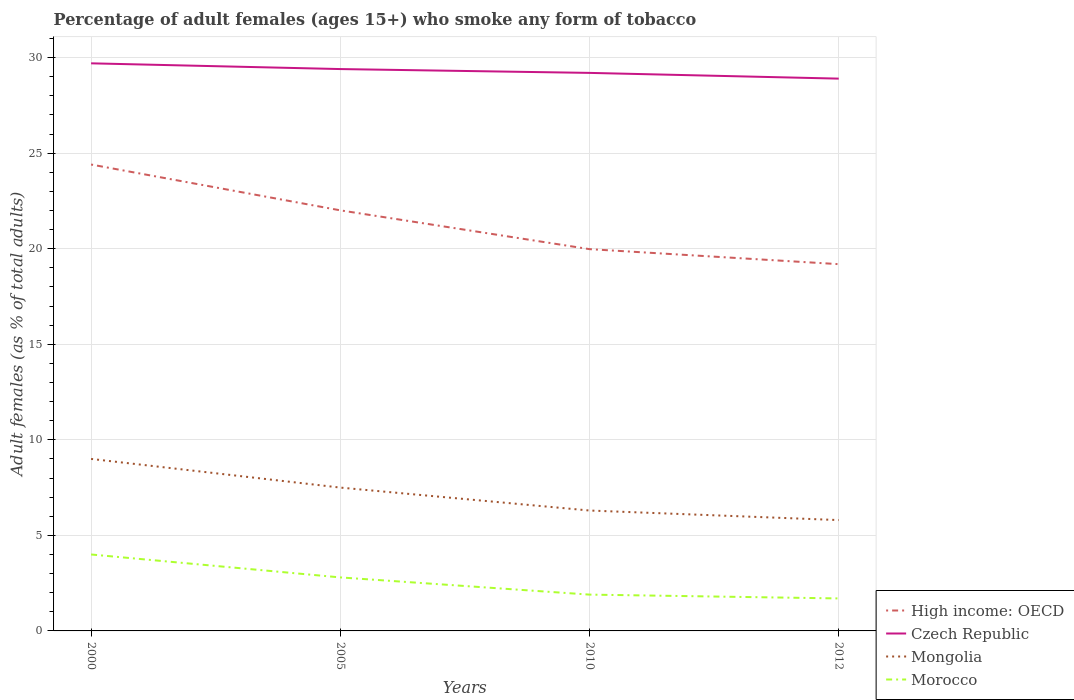How many different coloured lines are there?
Ensure brevity in your answer.  4. Does the line corresponding to Morocco intersect with the line corresponding to Mongolia?
Offer a very short reply. No. Across all years, what is the maximum percentage of adult females who smoke in Czech Republic?
Provide a succinct answer. 28.9. What is the total percentage of adult females who smoke in High income: OECD in the graph?
Provide a succinct answer. 2.4. What is the difference between the highest and the second highest percentage of adult females who smoke in Mongolia?
Make the answer very short. 3.2. What is the difference between the highest and the lowest percentage of adult females who smoke in Mongolia?
Keep it short and to the point. 2. Is the percentage of adult females who smoke in Czech Republic strictly greater than the percentage of adult females who smoke in Morocco over the years?
Make the answer very short. No. How many lines are there?
Keep it short and to the point. 4. How many years are there in the graph?
Your answer should be compact. 4. Are the values on the major ticks of Y-axis written in scientific E-notation?
Your response must be concise. No. Does the graph contain grids?
Offer a very short reply. Yes. How many legend labels are there?
Offer a terse response. 4. What is the title of the graph?
Ensure brevity in your answer.  Percentage of adult females (ages 15+) who smoke any form of tobacco. Does "Kenya" appear as one of the legend labels in the graph?
Your answer should be compact. No. What is the label or title of the X-axis?
Your answer should be very brief. Years. What is the label or title of the Y-axis?
Provide a succinct answer. Adult females (as % of total adults). What is the Adult females (as % of total adults) of High income: OECD in 2000?
Your answer should be compact. 24.4. What is the Adult females (as % of total adults) of Czech Republic in 2000?
Give a very brief answer. 29.7. What is the Adult females (as % of total adults) in High income: OECD in 2005?
Provide a succinct answer. 22.01. What is the Adult females (as % of total adults) in Czech Republic in 2005?
Your answer should be compact. 29.4. What is the Adult females (as % of total adults) in High income: OECD in 2010?
Offer a very short reply. 19.98. What is the Adult females (as % of total adults) of Czech Republic in 2010?
Provide a short and direct response. 29.2. What is the Adult females (as % of total adults) in Mongolia in 2010?
Your answer should be compact. 6.3. What is the Adult females (as % of total adults) in High income: OECD in 2012?
Offer a very short reply. 19.19. What is the Adult females (as % of total adults) of Czech Republic in 2012?
Offer a terse response. 28.9. What is the Adult females (as % of total adults) of Morocco in 2012?
Provide a succinct answer. 1.7. Across all years, what is the maximum Adult females (as % of total adults) in High income: OECD?
Provide a succinct answer. 24.4. Across all years, what is the maximum Adult females (as % of total adults) of Czech Republic?
Provide a succinct answer. 29.7. Across all years, what is the maximum Adult females (as % of total adults) of Morocco?
Offer a very short reply. 4. Across all years, what is the minimum Adult females (as % of total adults) of High income: OECD?
Make the answer very short. 19.19. Across all years, what is the minimum Adult females (as % of total adults) of Czech Republic?
Provide a succinct answer. 28.9. Across all years, what is the minimum Adult females (as % of total adults) in Mongolia?
Keep it short and to the point. 5.8. Across all years, what is the minimum Adult females (as % of total adults) in Morocco?
Keep it short and to the point. 1.7. What is the total Adult females (as % of total adults) in High income: OECD in the graph?
Give a very brief answer. 85.58. What is the total Adult females (as % of total adults) of Czech Republic in the graph?
Your response must be concise. 117.2. What is the total Adult females (as % of total adults) of Mongolia in the graph?
Your answer should be very brief. 28.6. What is the total Adult females (as % of total adults) of Morocco in the graph?
Your answer should be very brief. 10.4. What is the difference between the Adult females (as % of total adults) in High income: OECD in 2000 and that in 2005?
Provide a succinct answer. 2.4. What is the difference between the Adult females (as % of total adults) of Czech Republic in 2000 and that in 2005?
Provide a succinct answer. 0.3. What is the difference between the Adult females (as % of total adults) of Mongolia in 2000 and that in 2005?
Offer a terse response. 1.5. What is the difference between the Adult females (as % of total adults) in Morocco in 2000 and that in 2005?
Ensure brevity in your answer.  1.2. What is the difference between the Adult females (as % of total adults) of High income: OECD in 2000 and that in 2010?
Your answer should be compact. 4.43. What is the difference between the Adult females (as % of total adults) of Mongolia in 2000 and that in 2010?
Keep it short and to the point. 2.7. What is the difference between the Adult females (as % of total adults) in Morocco in 2000 and that in 2010?
Make the answer very short. 2.1. What is the difference between the Adult females (as % of total adults) in High income: OECD in 2000 and that in 2012?
Offer a terse response. 5.21. What is the difference between the Adult females (as % of total adults) in Czech Republic in 2000 and that in 2012?
Provide a short and direct response. 0.8. What is the difference between the Adult females (as % of total adults) in Mongolia in 2000 and that in 2012?
Offer a very short reply. 3.2. What is the difference between the Adult females (as % of total adults) in Morocco in 2000 and that in 2012?
Offer a very short reply. 2.3. What is the difference between the Adult females (as % of total adults) in High income: OECD in 2005 and that in 2010?
Offer a terse response. 2.03. What is the difference between the Adult females (as % of total adults) of Czech Republic in 2005 and that in 2010?
Your answer should be compact. 0.2. What is the difference between the Adult females (as % of total adults) of Mongolia in 2005 and that in 2010?
Provide a short and direct response. 1.2. What is the difference between the Adult females (as % of total adults) in High income: OECD in 2005 and that in 2012?
Give a very brief answer. 2.82. What is the difference between the Adult females (as % of total adults) of Morocco in 2005 and that in 2012?
Your response must be concise. 1.1. What is the difference between the Adult females (as % of total adults) in High income: OECD in 2010 and that in 2012?
Offer a terse response. 0.79. What is the difference between the Adult females (as % of total adults) of Czech Republic in 2010 and that in 2012?
Your answer should be very brief. 0.3. What is the difference between the Adult females (as % of total adults) in Mongolia in 2010 and that in 2012?
Offer a terse response. 0.5. What is the difference between the Adult females (as % of total adults) of Morocco in 2010 and that in 2012?
Keep it short and to the point. 0.2. What is the difference between the Adult females (as % of total adults) of High income: OECD in 2000 and the Adult females (as % of total adults) of Czech Republic in 2005?
Your answer should be very brief. -5. What is the difference between the Adult females (as % of total adults) in High income: OECD in 2000 and the Adult females (as % of total adults) in Mongolia in 2005?
Your answer should be compact. 16.9. What is the difference between the Adult females (as % of total adults) of High income: OECD in 2000 and the Adult females (as % of total adults) of Morocco in 2005?
Provide a short and direct response. 21.6. What is the difference between the Adult females (as % of total adults) in Czech Republic in 2000 and the Adult females (as % of total adults) in Mongolia in 2005?
Offer a terse response. 22.2. What is the difference between the Adult females (as % of total adults) in Czech Republic in 2000 and the Adult females (as % of total adults) in Morocco in 2005?
Offer a terse response. 26.9. What is the difference between the Adult females (as % of total adults) in High income: OECD in 2000 and the Adult females (as % of total adults) in Czech Republic in 2010?
Your response must be concise. -4.8. What is the difference between the Adult females (as % of total adults) of High income: OECD in 2000 and the Adult females (as % of total adults) of Mongolia in 2010?
Ensure brevity in your answer.  18.1. What is the difference between the Adult females (as % of total adults) in High income: OECD in 2000 and the Adult females (as % of total adults) in Morocco in 2010?
Ensure brevity in your answer.  22.5. What is the difference between the Adult females (as % of total adults) of Czech Republic in 2000 and the Adult females (as % of total adults) of Mongolia in 2010?
Make the answer very short. 23.4. What is the difference between the Adult females (as % of total adults) of Czech Republic in 2000 and the Adult females (as % of total adults) of Morocco in 2010?
Offer a terse response. 27.8. What is the difference between the Adult females (as % of total adults) of Mongolia in 2000 and the Adult females (as % of total adults) of Morocco in 2010?
Your answer should be compact. 7.1. What is the difference between the Adult females (as % of total adults) in High income: OECD in 2000 and the Adult females (as % of total adults) in Czech Republic in 2012?
Your answer should be compact. -4.5. What is the difference between the Adult females (as % of total adults) in High income: OECD in 2000 and the Adult females (as % of total adults) in Mongolia in 2012?
Keep it short and to the point. 18.6. What is the difference between the Adult females (as % of total adults) of High income: OECD in 2000 and the Adult females (as % of total adults) of Morocco in 2012?
Offer a terse response. 22.7. What is the difference between the Adult females (as % of total adults) of Czech Republic in 2000 and the Adult females (as % of total adults) of Mongolia in 2012?
Make the answer very short. 23.9. What is the difference between the Adult females (as % of total adults) in Czech Republic in 2000 and the Adult females (as % of total adults) in Morocco in 2012?
Your answer should be very brief. 28. What is the difference between the Adult females (as % of total adults) in High income: OECD in 2005 and the Adult females (as % of total adults) in Czech Republic in 2010?
Offer a very short reply. -7.19. What is the difference between the Adult females (as % of total adults) in High income: OECD in 2005 and the Adult females (as % of total adults) in Mongolia in 2010?
Provide a succinct answer. 15.71. What is the difference between the Adult females (as % of total adults) of High income: OECD in 2005 and the Adult females (as % of total adults) of Morocco in 2010?
Provide a short and direct response. 20.11. What is the difference between the Adult females (as % of total adults) of Czech Republic in 2005 and the Adult females (as % of total adults) of Mongolia in 2010?
Make the answer very short. 23.1. What is the difference between the Adult females (as % of total adults) in Mongolia in 2005 and the Adult females (as % of total adults) in Morocco in 2010?
Provide a succinct answer. 5.6. What is the difference between the Adult females (as % of total adults) of High income: OECD in 2005 and the Adult females (as % of total adults) of Czech Republic in 2012?
Offer a very short reply. -6.89. What is the difference between the Adult females (as % of total adults) of High income: OECD in 2005 and the Adult females (as % of total adults) of Mongolia in 2012?
Provide a short and direct response. 16.21. What is the difference between the Adult females (as % of total adults) of High income: OECD in 2005 and the Adult females (as % of total adults) of Morocco in 2012?
Give a very brief answer. 20.31. What is the difference between the Adult females (as % of total adults) of Czech Republic in 2005 and the Adult females (as % of total adults) of Mongolia in 2012?
Offer a terse response. 23.6. What is the difference between the Adult females (as % of total adults) of Czech Republic in 2005 and the Adult females (as % of total adults) of Morocco in 2012?
Provide a succinct answer. 27.7. What is the difference between the Adult females (as % of total adults) of Mongolia in 2005 and the Adult females (as % of total adults) of Morocco in 2012?
Ensure brevity in your answer.  5.8. What is the difference between the Adult females (as % of total adults) in High income: OECD in 2010 and the Adult females (as % of total adults) in Czech Republic in 2012?
Make the answer very short. -8.92. What is the difference between the Adult females (as % of total adults) of High income: OECD in 2010 and the Adult females (as % of total adults) of Mongolia in 2012?
Make the answer very short. 14.18. What is the difference between the Adult females (as % of total adults) in High income: OECD in 2010 and the Adult females (as % of total adults) in Morocco in 2012?
Offer a very short reply. 18.28. What is the difference between the Adult females (as % of total adults) in Czech Republic in 2010 and the Adult females (as % of total adults) in Mongolia in 2012?
Keep it short and to the point. 23.4. What is the difference between the Adult females (as % of total adults) of Czech Republic in 2010 and the Adult females (as % of total adults) of Morocco in 2012?
Offer a very short reply. 27.5. What is the average Adult females (as % of total adults) of High income: OECD per year?
Provide a succinct answer. 21.4. What is the average Adult females (as % of total adults) of Czech Republic per year?
Give a very brief answer. 29.3. What is the average Adult females (as % of total adults) in Mongolia per year?
Offer a very short reply. 7.15. In the year 2000, what is the difference between the Adult females (as % of total adults) in High income: OECD and Adult females (as % of total adults) in Czech Republic?
Offer a very short reply. -5.3. In the year 2000, what is the difference between the Adult females (as % of total adults) of High income: OECD and Adult females (as % of total adults) of Mongolia?
Give a very brief answer. 15.4. In the year 2000, what is the difference between the Adult females (as % of total adults) in High income: OECD and Adult females (as % of total adults) in Morocco?
Ensure brevity in your answer.  20.4. In the year 2000, what is the difference between the Adult females (as % of total adults) in Czech Republic and Adult females (as % of total adults) in Mongolia?
Make the answer very short. 20.7. In the year 2000, what is the difference between the Adult females (as % of total adults) in Czech Republic and Adult females (as % of total adults) in Morocco?
Offer a terse response. 25.7. In the year 2000, what is the difference between the Adult females (as % of total adults) of Mongolia and Adult females (as % of total adults) of Morocco?
Offer a terse response. 5. In the year 2005, what is the difference between the Adult females (as % of total adults) in High income: OECD and Adult females (as % of total adults) in Czech Republic?
Your response must be concise. -7.39. In the year 2005, what is the difference between the Adult females (as % of total adults) of High income: OECD and Adult females (as % of total adults) of Mongolia?
Offer a terse response. 14.51. In the year 2005, what is the difference between the Adult females (as % of total adults) of High income: OECD and Adult females (as % of total adults) of Morocco?
Give a very brief answer. 19.21. In the year 2005, what is the difference between the Adult females (as % of total adults) in Czech Republic and Adult females (as % of total adults) in Mongolia?
Offer a terse response. 21.9. In the year 2005, what is the difference between the Adult females (as % of total adults) of Czech Republic and Adult females (as % of total adults) of Morocco?
Offer a terse response. 26.6. In the year 2010, what is the difference between the Adult females (as % of total adults) of High income: OECD and Adult females (as % of total adults) of Czech Republic?
Ensure brevity in your answer.  -9.22. In the year 2010, what is the difference between the Adult females (as % of total adults) of High income: OECD and Adult females (as % of total adults) of Mongolia?
Keep it short and to the point. 13.68. In the year 2010, what is the difference between the Adult females (as % of total adults) of High income: OECD and Adult females (as % of total adults) of Morocco?
Offer a very short reply. 18.08. In the year 2010, what is the difference between the Adult females (as % of total adults) of Czech Republic and Adult females (as % of total adults) of Mongolia?
Provide a succinct answer. 22.9. In the year 2010, what is the difference between the Adult females (as % of total adults) of Czech Republic and Adult females (as % of total adults) of Morocco?
Give a very brief answer. 27.3. In the year 2012, what is the difference between the Adult females (as % of total adults) in High income: OECD and Adult females (as % of total adults) in Czech Republic?
Provide a short and direct response. -9.71. In the year 2012, what is the difference between the Adult females (as % of total adults) in High income: OECD and Adult females (as % of total adults) in Mongolia?
Provide a succinct answer. 13.39. In the year 2012, what is the difference between the Adult females (as % of total adults) of High income: OECD and Adult females (as % of total adults) of Morocco?
Provide a succinct answer. 17.49. In the year 2012, what is the difference between the Adult females (as % of total adults) in Czech Republic and Adult females (as % of total adults) in Mongolia?
Ensure brevity in your answer.  23.1. In the year 2012, what is the difference between the Adult females (as % of total adults) in Czech Republic and Adult females (as % of total adults) in Morocco?
Your answer should be compact. 27.2. In the year 2012, what is the difference between the Adult females (as % of total adults) of Mongolia and Adult females (as % of total adults) of Morocco?
Your response must be concise. 4.1. What is the ratio of the Adult females (as % of total adults) in High income: OECD in 2000 to that in 2005?
Your answer should be compact. 1.11. What is the ratio of the Adult females (as % of total adults) in Czech Republic in 2000 to that in 2005?
Give a very brief answer. 1.01. What is the ratio of the Adult females (as % of total adults) in Morocco in 2000 to that in 2005?
Provide a short and direct response. 1.43. What is the ratio of the Adult females (as % of total adults) in High income: OECD in 2000 to that in 2010?
Your response must be concise. 1.22. What is the ratio of the Adult females (as % of total adults) in Czech Republic in 2000 to that in 2010?
Provide a short and direct response. 1.02. What is the ratio of the Adult females (as % of total adults) of Mongolia in 2000 to that in 2010?
Offer a terse response. 1.43. What is the ratio of the Adult females (as % of total adults) in Morocco in 2000 to that in 2010?
Offer a terse response. 2.11. What is the ratio of the Adult females (as % of total adults) in High income: OECD in 2000 to that in 2012?
Ensure brevity in your answer.  1.27. What is the ratio of the Adult females (as % of total adults) in Czech Republic in 2000 to that in 2012?
Your response must be concise. 1.03. What is the ratio of the Adult females (as % of total adults) in Mongolia in 2000 to that in 2012?
Your response must be concise. 1.55. What is the ratio of the Adult females (as % of total adults) in Morocco in 2000 to that in 2012?
Give a very brief answer. 2.35. What is the ratio of the Adult females (as % of total adults) of High income: OECD in 2005 to that in 2010?
Ensure brevity in your answer.  1.1. What is the ratio of the Adult females (as % of total adults) in Czech Republic in 2005 to that in 2010?
Offer a terse response. 1.01. What is the ratio of the Adult females (as % of total adults) of Mongolia in 2005 to that in 2010?
Ensure brevity in your answer.  1.19. What is the ratio of the Adult females (as % of total adults) of Morocco in 2005 to that in 2010?
Your answer should be very brief. 1.47. What is the ratio of the Adult females (as % of total adults) of High income: OECD in 2005 to that in 2012?
Keep it short and to the point. 1.15. What is the ratio of the Adult females (as % of total adults) in Czech Republic in 2005 to that in 2012?
Your response must be concise. 1.02. What is the ratio of the Adult females (as % of total adults) of Mongolia in 2005 to that in 2012?
Provide a succinct answer. 1.29. What is the ratio of the Adult females (as % of total adults) of Morocco in 2005 to that in 2012?
Provide a short and direct response. 1.65. What is the ratio of the Adult females (as % of total adults) of High income: OECD in 2010 to that in 2012?
Your response must be concise. 1.04. What is the ratio of the Adult females (as % of total adults) of Czech Republic in 2010 to that in 2012?
Your answer should be very brief. 1.01. What is the ratio of the Adult females (as % of total adults) in Mongolia in 2010 to that in 2012?
Give a very brief answer. 1.09. What is the ratio of the Adult females (as % of total adults) of Morocco in 2010 to that in 2012?
Provide a short and direct response. 1.12. What is the difference between the highest and the second highest Adult females (as % of total adults) of High income: OECD?
Ensure brevity in your answer.  2.4. What is the difference between the highest and the second highest Adult females (as % of total adults) of Czech Republic?
Ensure brevity in your answer.  0.3. What is the difference between the highest and the lowest Adult females (as % of total adults) of High income: OECD?
Ensure brevity in your answer.  5.21. What is the difference between the highest and the lowest Adult females (as % of total adults) in Czech Republic?
Provide a short and direct response. 0.8. What is the difference between the highest and the lowest Adult females (as % of total adults) of Mongolia?
Provide a succinct answer. 3.2. 